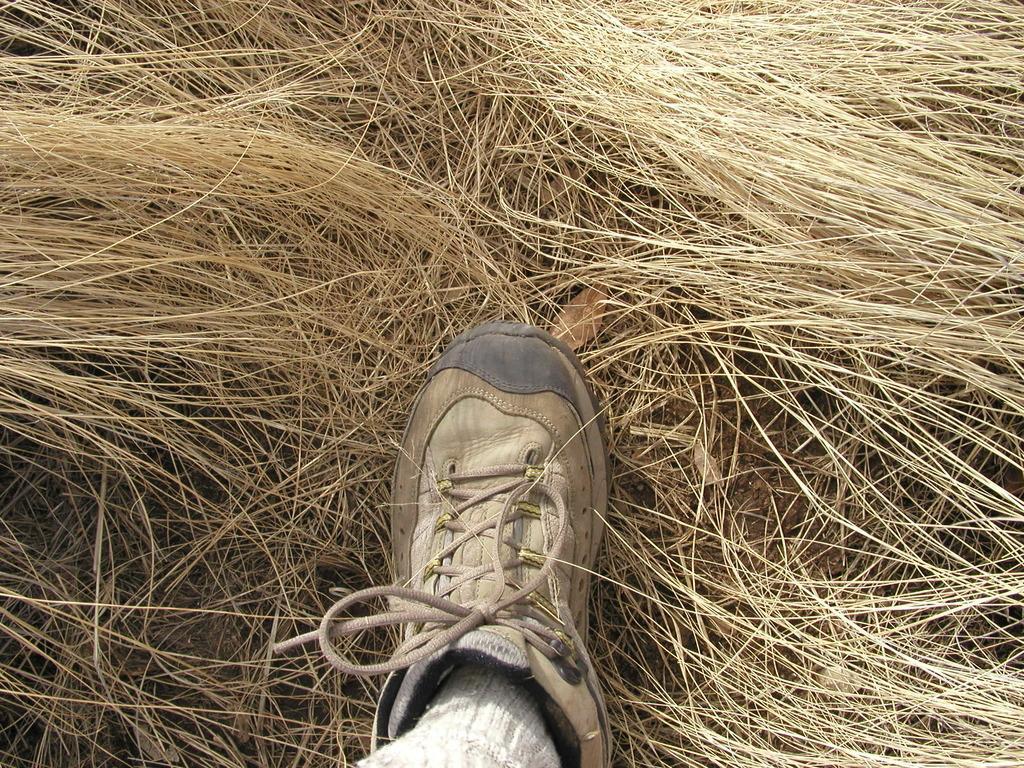Could you give a brief overview of what you see in this image? In this image in the center there is one person's leg is visible, and in the background there is grass. 